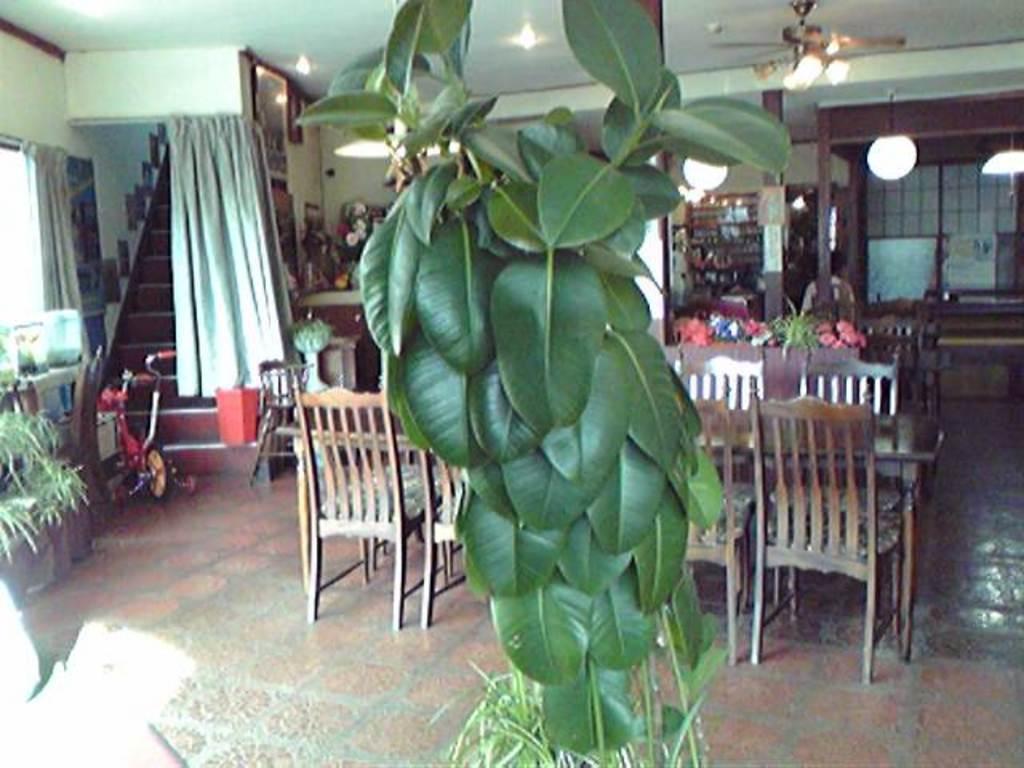How would you summarize this image in a sentence or two? In this picture I can see there is a plant here and it has leafs and there is a table in the backdrop and there are chairs around the table and there are few other plants on to left, there is a window, few objects and there is a bicycle, stairs a curtain and there is a door in the backdrop, there are few shelves and there are few objects placed in it. 